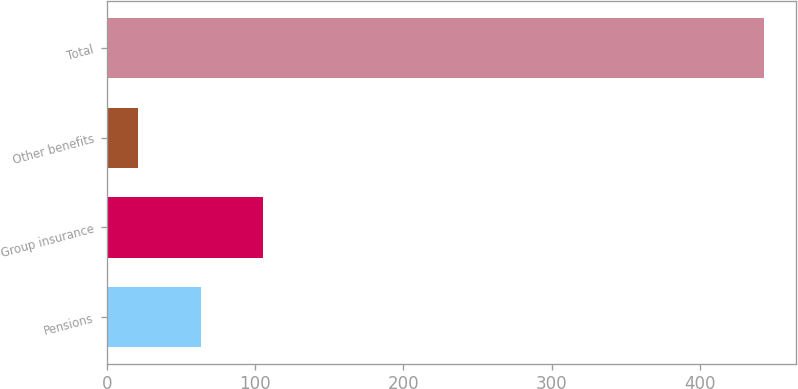Convert chart. <chart><loc_0><loc_0><loc_500><loc_500><bar_chart><fcel>Pensions<fcel>Group insurance<fcel>Other benefits<fcel>Total<nl><fcel>63.2<fcel>105.4<fcel>21<fcel>443<nl></chart> 